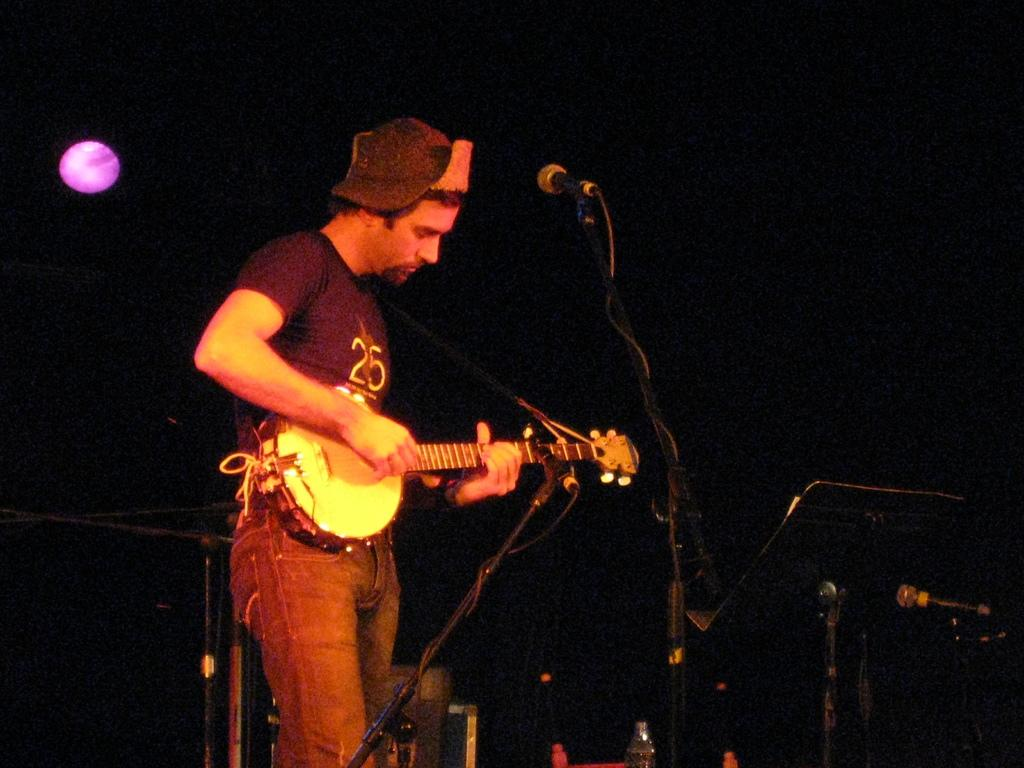What is the person on the left side of the image doing? The person is playing a guitar. What object is visible near the person in the image? There is a microphone visible in the image. What type of furniture can be seen in the background of the image? There is no furniture visible in the image. 